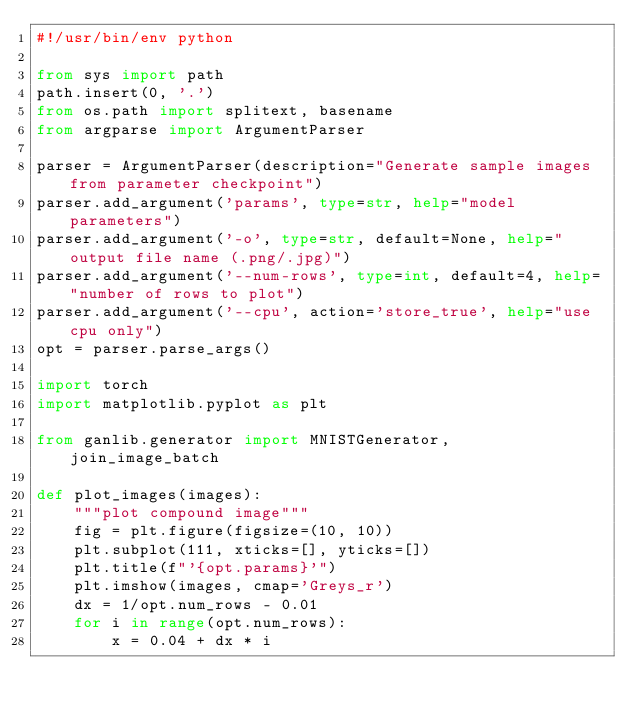<code> <loc_0><loc_0><loc_500><loc_500><_Python_>#!/usr/bin/env python

from sys import path
path.insert(0, '.')
from os.path import splitext, basename
from argparse import ArgumentParser

parser = ArgumentParser(description="Generate sample images from parameter checkpoint")
parser.add_argument('params', type=str, help="model parameters")
parser.add_argument('-o', type=str, default=None, help="output file name (.png/.jpg)")
parser.add_argument('--num-rows', type=int, default=4, help="number of rows to plot")
parser.add_argument('--cpu', action='store_true', help="use cpu only")
opt = parser.parse_args()

import torch
import matplotlib.pyplot as plt

from ganlib.generator import MNISTGenerator, join_image_batch

def plot_images(images):
    """plot compound image"""
    fig = plt.figure(figsize=(10, 10))
    plt.subplot(111, xticks=[], yticks=[])
    plt.title(f"'{opt.params}'")
    plt.imshow(images, cmap='Greys_r')
    dx = 1/opt.num_rows - 0.01
    for i in range(opt.num_rows):
        x = 0.04 + dx * i</code> 